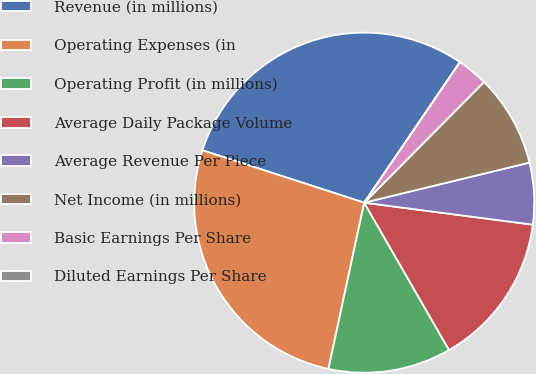Convert chart. <chart><loc_0><loc_0><loc_500><loc_500><pie_chart><fcel>Revenue (in millions)<fcel>Operating Expenses (in<fcel>Operating Profit (in millions)<fcel>Average Daily Package Volume<fcel>Average Revenue Per Piece<fcel>Net Income (in millions)<fcel>Basic Earnings Per Share<fcel>Diluted Earnings Per Share<nl><fcel>29.53%<fcel>26.61%<fcel>11.69%<fcel>14.62%<fcel>5.85%<fcel>8.77%<fcel>2.93%<fcel>0.0%<nl></chart> 